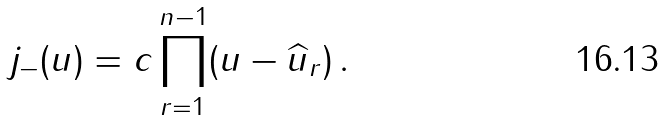<formula> <loc_0><loc_0><loc_500><loc_500>j _ { - } ( u ) = c \prod _ { r = 1 } ^ { n - 1 } ( u - \widehat { u } _ { r } ) \, .</formula> 